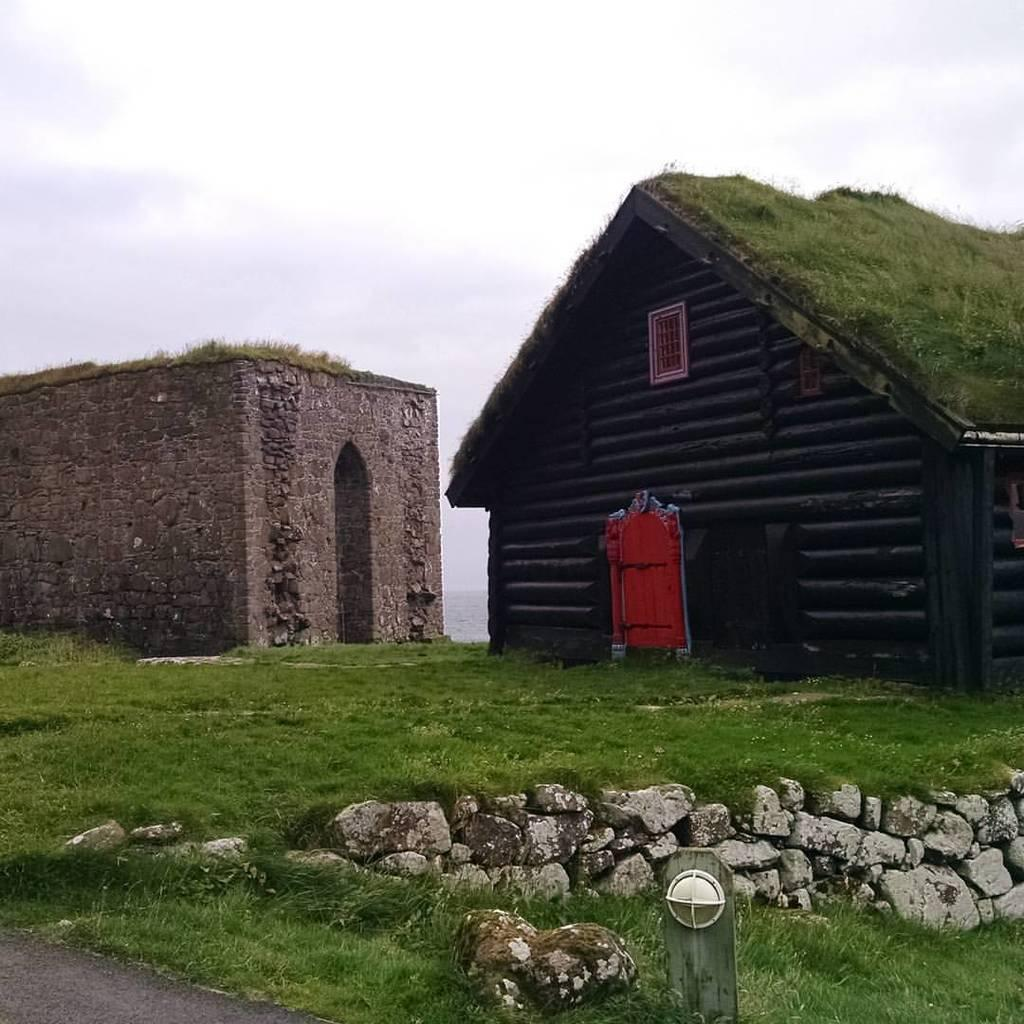What type of structures can be seen in the image? There are houses in the image. What can be found on the ground in the image? There are rocks and grass on the ground in the image. What is the condition of the sky in the image? The sky is cloudy in the image. What type of mint is growing on the roof of the house in the image? There is no mint growing on the roof of the house in the image; it only features houses, rocks, grass, and a cloudy sky. 